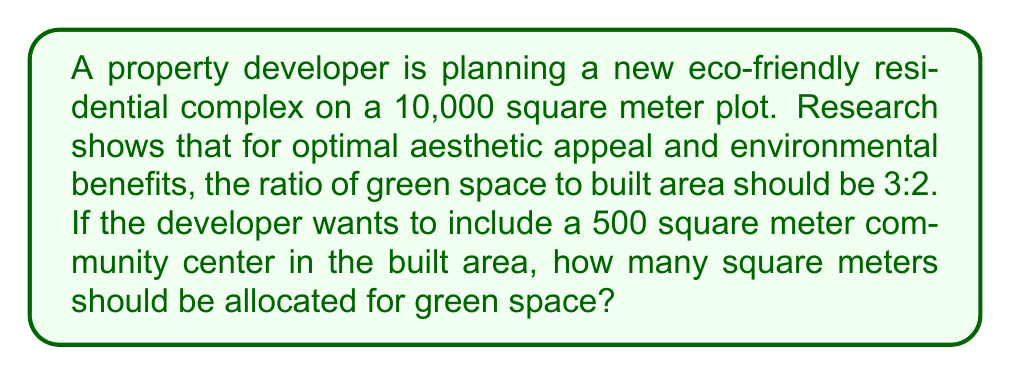Show me your answer to this math problem. Let's approach this step-by-step:

1) Let $x$ be the total built area in square meters.
   Let $y$ be the total green space in square meters.

2) We know that the ratio of green space to built area should be 3:2. This can be expressed as:

   $$\frac{y}{x} = \frac{3}{2}$$

3) We also know that the total area is 10,000 square meters:

   $$x + y = 10000$$

4) From the ratio equation, we can express $y$ in terms of $x$:

   $$y = \frac{3}{2}x$$

5) Substituting this into the total area equation:

   $$x + \frac{3}{2}x = 10000$$
   $$\frac{5}{2}x = 10000$$

6) Solving for $x$:

   $$x = \frac{10000 \cdot 2}{5} = 4000$$

7) So the total built area should be 4000 square meters, and the green space should be:

   $$y = 10000 - 4000 = 6000$$ square meters

8) However, we need to include the 500 square meter community center in the built area. This means we need to subtract 500 from the green space:

   $$6000 - 500 = 5500$$ square meters

Therefore, the optimal green space allocation is 5500 square meters.
Answer: 5500 square meters 